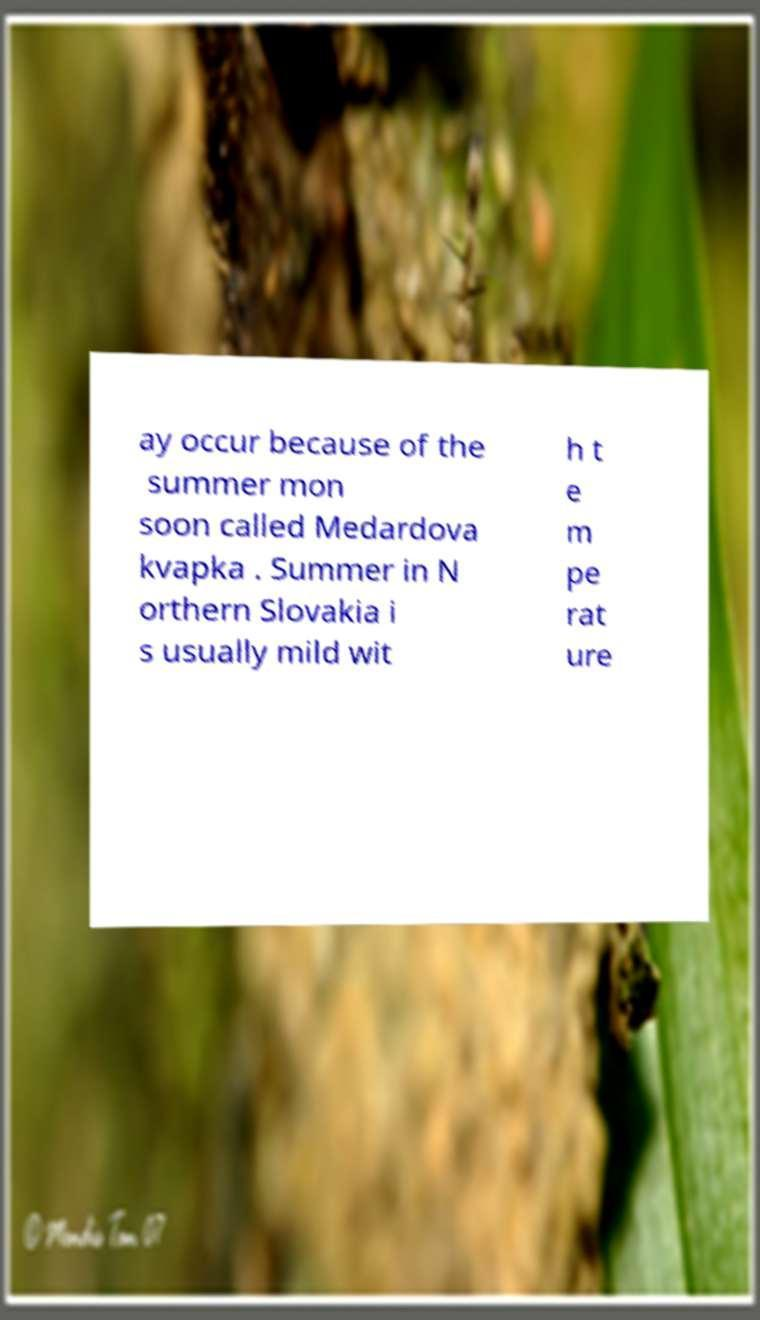What messages or text are displayed in this image? I need them in a readable, typed format. ay occur because of the summer mon soon called Medardova kvapka . Summer in N orthern Slovakia i s usually mild wit h t e m pe rat ure 